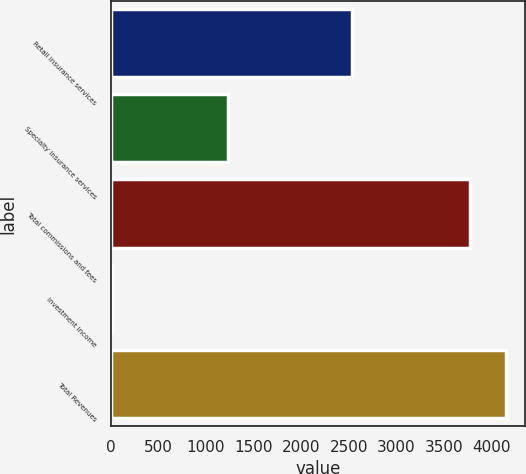Convert chart to OTSL. <chart><loc_0><loc_0><loc_500><loc_500><bar_chart><fcel>Retail insurance services<fcel>Specialty insurance services<fcel>Total commissions and fees<fcel>Investment income<fcel>Total Revenues<nl><fcel>2534<fcel>1233<fcel>3767<fcel>16<fcel>4145.6<nl></chart> 